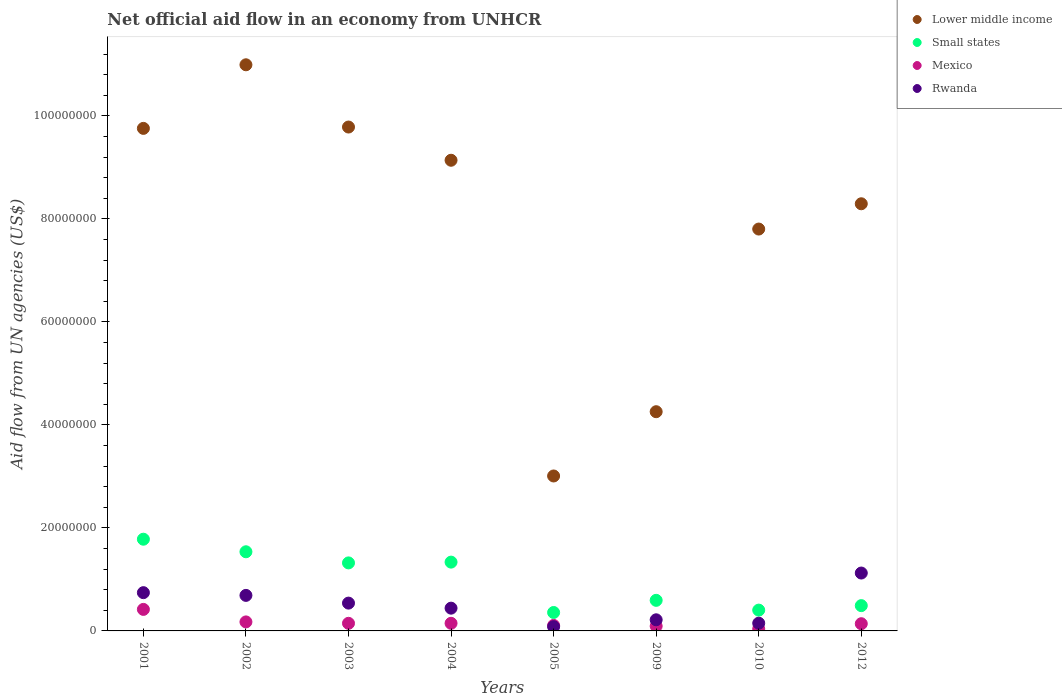How many different coloured dotlines are there?
Offer a terse response. 4. What is the net official aid flow in Rwanda in 2009?
Give a very brief answer. 2.16e+06. Across all years, what is the maximum net official aid flow in Lower middle income?
Provide a short and direct response. 1.10e+08. Across all years, what is the minimum net official aid flow in Small states?
Give a very brief answer. 3.58e+06. In which year was the net official aid flow in Rwanda maximum?
Keep it short and to the point. 2012. What is the total net official aid flow in Small states in the graph?
Your answer should be compact. 7.82e+07. What is the difference between the net official aid flow in Rwanda in 2002 and the net official aid flow in Mexico in 2009?
Keep it short and to the point. 5.97e+06. What is the average net official aid flow in Lower middle income per year?
Offer a terse response. 7.88e+07. In the year 2010, what is the difference between the net official aid flow in Small states and net official aid flow in Lower middle income?
Your answer should be compact. -7.40e+07. In how many years, is the net official aid flow in Rwanda greater than 88000000 US$?
Ensure brevity in your answer.  0. What is the ratio of the net official aid flow in Lower middle income in 2001 to that in 2003?
Keep it short and to the point. 1. What is the difference between the highest and the second highest net official aid flow in Rwanda?
Make the answer very short. 3.81e+06. What is the difference between the highest and the lowest net official aid flow in Small states?
Offer a very short reply. 1.42e+07. In how many years, is the net official aid flow in Lower middle income greater than the average net official aid flow in Lower middle income taken over all years?
Keep it short and to the point. 5. Is the sum of the net official aid flow in Lower middle income in 2005 and 2009 greater than the maximum net official aid flow in Mexico across all years?
Offer a very short reply. Yes. Is it the case that in every year, the sum of the net official aid flow in Lower middle income and net official aid flow in Rwanda  is greater than the sum of net official aid flow in Small states and net official aid flow in Mexico?
Provide a short and direct response. No. How many dotlines are there?
Your response must be concise. 4. What is the title of the graph?
Your answer should be very brief. Net official aid flow in an economy from UNHCR. What is the label or title of the Y-axis?
Provide a succinct answer. Aid flow from UN agencies (US$). What is the Aid flow from UN agencies (US$) in Lower middle income in 2001?
Offer a very short reply. 9.76e+07. What is the Aid flow from UN agencies (US$) of Small states in 2001?
Your response must be concise. 1.78e+07. What is the Aid flow from UN agencies (US$) of Mexico in 2001?
Provide a short and direct response. 4.18e+06. What is the Aid flow from UN agencies (US$) in Rwanda in 2001?
Your answer should be compact. 7.43e+06. What is the Aid flow from UN agencies (US$) of Lower middle income in 2002?
Make the answer very short. 1.10e+08. What is the Aid flow from UN agencies (US$) of Small states in 2002?
Make the answer very short. 1.54e+07. What is the Aid flow from UN agencies (US$) of Mexico in 2002?
Provide a short and direct response. 1.75e+06. What is the Aid flow from UN agencies (US$) of Rwanda in 2002?
Offer a very short reply. 6.90e+06. What is the Aid flow from UN agencies (US$) of Lower middle income in 2003?
Make the answer very short. 9.78e+07. What is the Aid flow from UN agencies (US$) of Small states in 2003?
Make the answer very short. 1.32e+07. What is the Aid flow from UN agencies (US$) of Mexico in 2003?
Offer a terse response. 1.48e+06. What is the Aid flow from UN agencies (US$) of Rwanda in 2003?
Give a very brief answer. 5.40e+06. What is the Aid flow from UN agencies (US$) in Lower middle income in 2004?
Ensure brevity in your answer.  9.14e+07. What is the Aid flow from UN agencies (US$) of Small states in 2004?
Your response must be concise. 1.34e+07. What is the Aid flow from UN agencies (US$) in Mexico in 2004?
Ensure brevity in your answer.  1.48e+06. What is the Aid flow from UN agencies (US$) in Rwanda in 2004?
Offer a terse response. 4.42e+06. What is the Aid flow from UN agencies (US$) of Lower middle income in 2005?
Keep it short and to the point. 3.01e+07. What is the Aid flow from UN agencies (US$) of Small states in 2005?
Ensure brevity in your answer.  3.58e+06. What is the Aid flow from UN agencies (US$) of Mexico in 2005?
Provide a succinct answer. 1.07e+06. What is the Aid flow from UN agencies (US$) in Rwanda in 2005?
Your answer should be very brief. 8.20e+05. What is the Aid flow from UN agencies (US$) of Lower middle income in 2009?
Your answer should be very brief. 4.26e+07. What is the Aid flow from UN agencies (US$) in Small states in 2009?
Offer a very short reply. 5.94e+06. What is the Aid flow from UN agencies (US$) in Mexico in 2009?
Your response must be concise. 9.30e+05. What is the Aid flow from UN agencies (US$) in Rwanda in 2009?
Give a very brief answer. 2.16e+06. What is the Aid flow from UN agencies (US$) in Lower middle income in 2010?
Make the answer very short. 7.80e+07. What is the Aid flow from UN agencies (US$) in Small states in 2010?
Make the answer very short. 4.04e+06. What is the Aid flow from UN agencies (US$) in Rwanda in 2010?
Provide a succinct answer. 1.50e+06. What is the Aid flow from UN agencies (US$) of Lower middle income in 2012?
Provide a short and direct response. 8.30e+07. What is the Aid flow from UN agencies (US$) of Small states in 2012?
Provide a succinct answer. 4.91e+06. What is the Aid flow from UN agencies (US$) of Mexico in 2012?
Provide a succinct answer. 1.40e+06. What is the Aid flow from UN agencies (US$) in Rwanda in 2012?
Your response must be concise. 1.12e+07. Across all years, what is the maximum Aid flow from UN agencies (US$) of Lower middle income?
Your answer should be very brief. 1.10e+08. Across all years, what is the maximum Aid flow from UN agencies (US$) of Small states?
Provide a succinct answer. 1.78e+07. Across all years, what is the maximum Aid flow from UN agencies (US$) in Mexico?
Offer a terse response. 4.18e+06. Across all years, what is the maximum Aid flow from UN agencies (US$) in Rwanda?
Offer a terse response. 1.12e+07. Across all years, what is the minimum Aid flow from UN agencies (US$) of Lower middle income?
Provide a succinct answer. 3.01e+07. Across all years, what is the minimum Aid flow from UN agencies (US$) in Small states?
Your answer should be very brief. 3.58e+06. Across all years, what is the minimum Aid flow from UN agencies (US$) of Mexico?
Keep it short and to the point. 3.90e+05. Across all years, what is the minimum Aid flow from UN agencies (US$) in Rwanda?
Your answer should be very brief. 8.20e+05. What is the total Aid flow from UN agencies (US$) of Lower middle income in the graph?
Your answer should be very brief. 6.30e+08. What is the total Aid flow from UN agencies (US$) in Small states in the graph?
Your answer should be very brief. 7.82e+07. What is the total Aid flow from UN agencies (US$) of Mexico in the graph?
Give a very brief answer. 1.27e+07. What is the total Aid flow from UN agencies (US$) of Rwanda in the graph?
Your answer should be very brief. 3.99e+07. What is the difference between the Aid flow from UN agencies (US$) of Lower middle income in 2001 and that in 2002?
Give a very brief answer. -1.24e+07. What is the difference between the Aid flow from UN agencies (US$) in Small states in 2001 and that in 2002?
Offer a very short reply. 2.44e+06. What is the difference between the Aid flow from UN agencies (US$) in Mexico in 2001 and that in 2002?
Offer a terse response. 2.43e+06. What is the difference between the Aid flow from UN agencies (US$) in Rwanda in 2001 and that in 2002?
Provide a short and direct response. 5.30e+05. What is the difference between the Aid flow from UN agencies (US$) of Lower middle income in 2001 and that in 2003?
Make the answer very short. -2.60e+05. What is the difference between the Aid flow from UN agencies (US$) of Small states in 2001 and that in 2003?
Provide a short and direct response. 4.60e+06. What is the difference between the Aid flow from UN agencies (US$) in Mexico in 2001 and that in 2003?
Offer a very short reply. 2.70e+06. What is the difference between the Aid flow from UN agencies (US$) in Rwanda in 2001 and that in 2003?
Make the answer very short. 2.03e+06. What is the difference between the Aid flow from UN agencies (US$) in Lower middle income in 2001 and that in 2004?
Ensure brevity in your answer.  6.19e+06. What is the difference between the Aid flow from UN agencies (US$) of Small states in 2001 and that in 2004?
Your response must be concise. 4.45e+06. What is the difference between the Aid flow from UN agencies (US$) in Mexico in 2001 and that in 2004?
Give a very brief answer. 2.70e+06. What is the difference between the Aid flow from UN agencies (US$) of Rwanda in 2001 and that in 2004?
Provide a short and direct response. 3.01e+06. What is the difference between the Aid flow from UN agencies (US$) in Lower middle income in 2001 and that in 2005?
Make the answer very short. 6.75e+07. What is the difference between the Aid flow from UN agencies (US$) in Small states in 2001 and that in 2005?
Your answer should be compact. 1.42e+07. What is the difference between the Aid flow from UN agencies (US$) of Mexico in 2001 and that in 2005?
Ensure brevity in your answer.  3.11e+06. What is the difference between the Aid flow from UN agencies (US$) of Rwanda in 2001 and that in 2005?
Offer a very short reply. 6.61e+06. What is the difference between the Aid flow from UN agencies (US$) in Lower middle income in 2001 and that in 2009?
Offer a terse response. 5.50e+07. What is the difference between the Aid flow from UN agencies (US$) in Small states in 2001 and that in 2009?
Offer a very short reply. 1.19e+07. What is the difference between the Aid flow from UN agencies (US$) of Mexico in 2001 and that in 2009?
Your response must be concise. 3.25e+06. What is the difference between the Aid flow from UN agencies (US$) in Rwanda in 2001 and that in 2009?
Make the answer very short. 5.27e+06. What is the difference between the Aid flow from UN agencies (US$) of Lower middle income in 2001 and that in 2010?
Give a very brief answer. 1.96e+07. What is the difference between the Aid flow from UN agencies (US$) in Small states in 2001 and that in 2010?
Your answer should be very brief. 1.38e+07. What is the difference between the Aid flow from UN agencies (US$) in Mexico in 2001 and that in 2010?
Your answer should be very brief. 3.79e+06. What is the difference between the Aid flow from UN agencies (US$) in Rwanda in 2001 and that in 2010?
Your answer should be very brief. 5.93e+06. What is the difference between the Aid flow from UN agencies (US$) in Lower middle income in 2001 and that in 2012?
Provide a succinct answer. 1.46e+07. What is the difference between the Aid flow from UN agencies (US$) in Small states in 2001 and that in 2012?
Your response must be concise. 1.29e+07. What is the difference between the Aid flow from UN agencies (US$) of Mexico in 2001 and that in 2012?
Keep it short and to the point. 2.78e+06. What is the difference between the Aid flow from UN agencies (US$) of Rwanda in 2001 and that in 2012?
Keep it short and to the point. -3.81e+06. What is the difference between the Aid flow from UN agencies (US$) in Lower middle income in 2002 and that in 2003?
Offer a terse response. 1.21e+07. What is the difference between the Aid flow from UN agencies (US$) of Small states in 2002 and that in 2003?
Give a very brief answer. 2.16e+06. What is the difference between the Aid flow from UN agencies (US$) in Mexico in 2002 and that in 2003?
Give a very brief answer. 2.70e+05. What is the difference between the Aid flow from UN agencies (US$) in Rwanda in 2002 and that in 2003?
Offer a terse response. 1.50e+06. What is the difference between the Aid flow from UN agencies (US$) in Lower middle income in 2002 and that in 2004?
Keep it short and to the point. 1.85e+07. What is the difference between the Aid flow from UN agencies (US$) in Small states in 2002 and that in 2004?
Your answer should be very brief. 2.01e+06. What is the difference between the Aid flow from UN agencies (US$) of Rwanda in 2002 and that in 2004?
Offer a terse response. 2.48e+06. What is the difference between the Aid flow from UN agencies (US$) in Lower middle income in 2002 and that in 2005?
Ensure brevity in your answer.  7.98e+07. What is the difference between the Aid flow from UN agencies (US$) of Small states in 2002 and that in 2005?
Your response must be concise. 1.18e+07. What is the difference between the Aid flow from UN agencies (US$) in Mexico in 2002 and that in 2005?
Provide a succinct answer. 6.80e+05. What is the difference between the Aid flow from UN agencies (US$) of Rwanda in 2002 and that in 2005?
Provide a succinct answer. 6.08e+06. What is the difference between the Aid flow from UN agencies (US$) of Lower middle income in 2002 and that in 2009?
Offer a very short reply. 6.74e+07. What is the difference between the Aid flow from UN agencies (US$) of Small states in 2002 and that in 2009?
Your answer should be very brief. 9.43e+06. What is the difference between the Aid flow from UN agencies (US$) in Mexico in 2002 and that in 2009?
Offer a very short reply. 8.20e+05. What is the difference between the Aid flow from UN agencies (US$) in Rwanda in 2002 and that in 2009?
Keep it short and to the point. 4.74e+06. What is the difference between the Aid flow from UN agencies (US$) in Lower middle income in 2002 and that in 2010?
Give a very brief answer. 3.19e+07. What is the difference between the Aid flow from UN agencies (US$) of Small states in 2002 and that in 2010?
Give a very brief answer. 1.13e+07. What is the difference between the Aid flow from UN agencies (US$) in Mexico in 2002 and that in 2010?
Provide a short and direct response. 1.36e+06. What is the difference between the Aid flow from UN agencies (US$) of Rwanda in 2002 and that in 2010?
Offer a terse response. 5.40e+06. What is the difference between the Aid flow from UN agencies (US$) of Lower middle income in 2002 and that in 2012?
Make the answer very short. 2.70e+07. What is the difference between the Aid flow from UN agencies (US$) in Small states in 2002 and that in 2012?
Make the answer very short. 1.05e+07. What is the difference between the Aid flow from UN agencies (US$) of Mexico in 2002 and that in 2012?
Your answer should be compact. 3.50e+05. What is the difference between the Aid flow from UN agencies (US$) in Rwanda in 2002 and that in 2012?
Your response must be concise. -4.34e+06. What is the difference between the Aid flow from UN agencies (US$) in Lower middle income in 2003 and that in 2004?
Provide a short and direct response. 6.45e+06. What is the difference between the Aid flow from UN agencies (US$) in Small states in 2003 and that in 2004?
Offer a very short reply. -1.50e+05. What is the difference between the Aid flow from UN agencies (US$) in Rwanda in 2003 and that in 2004?
Keep it short and to the point. 9.80e+05. What is the difference between the Aid flow from UN agencies (US$) in Lower middle income in 2003 and that in 2005?
Provide a short and direct response. 6.78e+07. What is the difference between the Aid flow from UN agencies (US$) of Small states in 2003 and that in 2005?
Keep it short and to the point. 9.63e+06. What is the difference between the Aid flow from UN agencies (US$) of Mexico in 2003 and that in 2005?
Provide a short and direct response. 4.10e+05. What is the difference between the Aid flow from UN agencies (US$) of Rwanda in 2003 and that in 2005?
Your answer should be compact. 4.58e+06. What is the difference between the Aid flow from UN agencies (US$) in Lower middle income in 2003 and that in 2009?
Provide a short and direct response. 5.53e+07. What is the difference between the Aid flow from UN agencies (US$) in Small states in 2003 and that in 2009?
Provide a succinct answer. 7.27e+06. What is the difference between the Aid flow from UN agencies (US$) in Rwanda in 2003 and that in 2009?
Make the answer very short. 3.24e+06. What is the difference between the Aid flow from UN agencies (US$) in Lower middle income in 2003 and that in 2010?
Ensure brevity in your answer.  1.98e+07. What is the difference between the Aid flow from UN agencies (US$) of Small states in 2003 and that in 2010?
Provide a short and direct response. 9.17e+06. What is the difference between the Aid flow from UN agencies (US$) of Mexico in 2003 and that in 2010?
Provide a short and direct response. 1.09e+06. What is the difference between the Aid flow from UN agencies (US$) of Rwanda in 2003 and that in 2010?
Your answer should be compact. 3.90e+06. What is the difference between the Aid flow from UN agencies (US$) of Lower middle income in 2003 and that in 2012?
Provide a succinct answer. 1.49e+07. What is the difference between the Aid flow from UN agencies (US$) of Small states in 2003 and that in 2012?
Offer a very short reply. 8.30e+06. What is the difference between the Aid flow from UN agencies (US$) in Rwanda in 2003 and that in 2012?
Make the answer very short. -5.84e+06. What is the difference between the Aid flow from UN agencies (US$) in Lower middle income in 2004 and that in 2005?
Provide a short and direct response. 6.13e+07. What is the difference between the Aid flow from UN agencies (US$) of Small states in 2004 and that in 2005?
Your answer should be compact. 9.78e+06. What is the difference between the Aid flow from UN agencies (US$) in Mexico in 2004 and that in 2005?
Provide a short and direct response. 4.10e+05. What is the difference between the Aid flow from UN agencies (US$) of Rwanda in 2004 and that in 2005?
Give a very brief answer. 3.60e+06. What is the difference between the Aid flow from UN agencies (US$) of Lower middle income in 2004 and that in 2009?
Keep it short and to the point. 4.88e+07. What is the difference between the Aid flow from UN agencies (US$) of Small states in 2004 and that in 2009?
Make the answer very short. 7.42e+06. What is the difference between the Aid flow from UN agencies (US$) of Mexico in 2004 and that in 2009?
Your response must be concise. 5.50e+05. What is the difference between the Aid flow from UN agencies (US$) in Rwanda in 2004 and that in 2009?
Provide a short and direct response. 2.26e+06. What is the difference between the Aid flow from UN agencies (US$) of Lower middle income in 2004 and that in 2010?
Make the answer very short. 1.34e+07. What is the difference between the Aid flow from UN agencies (US$) of Small states in 2004 and that in 2010?
Ensure brevity in your answer.  9.32e+06. What is the difference between the Aid flow from UN agencies (US$) in Mexico in 2004 and that in 2010?
Offer a terse response. 1.09e+06. What is the difference between the Aid flow from UN agencies (US$) of Rwanda in 2004 and that in 2010?
Offer a terse response. 2.92e+06. What is the difference between the Aid flow from UN agencies (US$) in Lower middle income in 2004 and that in 2012?
Ensure brevity in your answer.  8.45e+06. What is the difference between the Aid flow from UN agencies (US$) in Small states in 2004 and that in 2012?
Ensure brevity in your answer.  8.45e+06. What is the difference between the Aid flow from UN agencies (US$) of Rwanda in 2004 and that in 2012?
Provide a succinct answer. -6.82e+06. What is the difference between the Aid flow from UN agencies (US$) in Lower middle income in 2005 and that in 2009?
Keep it short and to the point. -1.25e+07. What is the difference between the Aid flow from UN agencies (US$) in Small states in 2005 and that in 2009?
Provide a short and direct response. -2.36e+06. What is the difference between the Aid flow from UN agencies (US$) in Rwanda in 2005 and that in 2009?
Offer a terse response. -1.34e+06. What is the difference between the Aid flow from UN agencies (US$) in Lower middle income in 2005 and that in 2010?
Offer a terse response. -4.80e+07. What is the difference between the Aid flow from UN agencies (US$) of Small states in 2005 and that in 2010?
Provide a short and direct response. -4.60e+05. What is the difference between the Aid flow from UN agencies (US$) of Mexico in 2005 and that in 2010?
Your answer should be compact. 6.80e+05. What is the difference between the Aid flow from UN agencies (US$) in Rwanda in 2005 and that in 2010?
Offer a very short reply. -6.80e+05. What is the difference between the Aid flow from UN agencies (US$) in Lower middle income in 2005 and that in 2012?
Give a very brief answer. -5.29e+07. What is the difference between the Aid flow from UN agencies (US$) of Small states in 2005 and that in 2012?
Keep it short and to the point. -1.33e+06. What is the difference between the Aid flow from UN agencies (US$) in Mexico in 2005 and that in 2012?
Make the answer very short. -3.30e+05. What is the difference between the Aid flow from UN agencies (US$) in Rwanda in 2005 and that in 2012?
Ensure brevity in your answer.  -1.04e+07. What is the difference between the Aid flow from UN agencies (US$) of Lower middle income in 2009 and that in 2010?
Provide a short and direct response. -3.55e+07. What is the difference between the Aid flow from UN agencies (US$) of Small states in 2009 and that in 2010?
Ensure brevity in your answer.  1.90e+06. What is the difference between the Aid flow from UN agencies (US$) in Mexico in 2009 and that in 2010?
Keep it short and to the point. 5.40e+05. What is the difference between the Aid flow from UN agencies (US$) of Lower middle income in 2009 and that in 2012?
Provide a short and direct response. -4.04e+07. What is the difference between the Aid flow from UN agencies (US$) in Small states in 2009 and that in 2012?
Offer a very short reply. 1.03e+06. What is the difference between the Aid flow from UN agencies (US$) in Mexico in 2009 and that in 2012?
Your answer should be very brief. -4.70e+05. What is the difference between the Aid flow from UN agencies (US$) in Rwanda in 2009 and that in 2012?
Offer a terse response. -9.08e+06. What is the difference between the Aid flow from UN agencies (US$) in Lower middle income in 2010 and that in 2012?
Offer a terse response. -4.91e+06. What is the difference between the Aid flow from UN agencies (US$) of Small states in 2010 and that in 2012?
Your response must be concise. -8.70e+05. What is the difference between the Aid flow from UN agencies (US$) of Mexico in 2010 and that in 2012?
Provide a succinct answer. -1.01e+06. What is the difference between the Aid flow from UN agencies (US$) in Rwanda in 2010 and that in 2012?
Make the answer very short. -9.74e+06. What is the difference between the Aid flow from UN agencies (US$) of Lower middle income in 2001 and the Aid flow from UN agencies (US$) of Small states in 2002?
Your response must be concise. 8.22e+07. What is the difference between the Aid flow from UN agencies (US$) in Lower middle income in 2001 and the Aid flow from UN agencies (US$) in Mexico in 2002?
Provide a succinct answer. 9.58e+07. What is the difference between the Aid flow from UN agencies (US$) in Lower middle income in 2001 and the Aid flow from UN agencies (US$) in Rwanda in 2002?
Make the answer very short. 9.07e+07. What is the difference between the Aid flow from UN agencies (US$) in Small states in 2001 and the Aid flow from UN agencies (US$) in Mexico in 2002?
Your answer should be compact. 1.61e+07. What is the difference between the Aid flow from UN agencies (US$) of Small states in 2001 and the Aid flow from UN agencies (US$) of Rwanda in 2002?
Ensure brevity in your answer.  1.09e+07. What is the difference between the Aid flow from UN agencies (US$) of Mexico in 2001 and the Aid flow from UN agencies (US$) of Rwanda in 2002?
Your answer should be compact. -2.72e+06. What is the difference between the Aid flow from UN agencies (US$) of Lower middle income in 2001 and the Aid flow from UN agencies (US$) of Small states in 2003?
Your answer should be very brief. 8.44e+07. What is the difference between the Aid flow from UN agencies (US$) of Lower middle income in 2001 and the Aid flow from UN agencies (US$) of Mexico in 2003?
Offer a very short reply. 9.61e+07. What is the difference between the Aid flow from UN agencies (US$) in Lower middle income in 2001 and the Aid flow from UN agencies (US$) in Rwanda in 2003?
Offer a terse response. 9.22e+07. What is the difference between the Aid flow from UN agencies (US$) of Small states in 2001 and the Aid flow from UN agencies (US$) of Mexico in 2003?
Ensure brevity in your answer.  1.63e+07. What is the difference between the Aid flow from UN agencies (US$) in Small states in 2001 and the Aid flow from UN agencies (US$) in Rwanda in 2003?
Your answer should be very brief. 1.24e+07. What is the difference between the Aid flow from UN agencies (US$) of Mexico in 2001 and the Aid flow from UN agencies (US$) of Rwanda in 2003?
Provide a short and direct response. -1.22e+06. What is the difference between the Aid flow from UN agencies (US$) of Lower middle income in 2001 and the Aid flow from UN agencies (US$) of Small states in 2004?
Make the answer very short. 8.42e+07. What is the difference between the Aid flow from UN agencies (US$) in Lower middle income in 2001 and the Aid flow from UN agencies (US$) in Mexico in 2004?
Make the answer very short. 9.61e+07. What is the difference between the Aid flow from UN agencies (US$) in Lower middle income in 2001 and the Aid flow from UN agencies (US$) in Rwanda in 2004?
Keep it short and to the point. 9.32e+07. What is the difference between the Aid flow from UN agencies (US$) of Small states in 2001 and the Aid flow from UN agencies (US$) of Mexico in 2004?
Your answer should be compact. 1.63e+07. What is the difference between the Aid flow from UN agencies (US$) of Small states in 2001 and the Aid flow from UN agencies (US$) of Rwanda in 2004?
Provide a succinct answer. 1.34e+07. What is the difference between the Aid flow from UN agencies (US$) of Mexico in 2001 and the Aid flow from UN agencies (US$) of Rwanda in 2004?
Provide a succinct answer. -2.40e+05. What is the difference between the Aid flow from UN agencies (US$) in Lower middle income in 2001 and the Aid flow from UN agencies (US$) in Small states in 2005?
Give a very brief answer. 9.40e+07. What is the difference between the Aid flow from UN agencies (US$) of Lower middle income in 2001 and the Aid flow from UN agencies (US$) of Mexico in 2005?
Your answer should be very brief. 9.65e+07. What is the difference between the Aid flow from UN agencies (US$) in Lower middle income in 2001 and the Aid flow from UN agencies (US$) in Rwanda in 2005?
Your response must be concise. 9.68e+07. What is the difference between the Aid flow from UN agencies (US$) of Small states in 2001 and the Aid flow from UN agencies (US$) of Mexico in 2005?
Your answer should be very brief. 1.67e+07. What is the difference between the Aid flow from UN agencies (US$) in Small states in 2001 and the Aid flow from UN agencies (US$) in Rwanda in 2005?
Give a very brief answer. 1.70e+07. What is the difference between the Aid flow from UN agencies (US$) of Mexico in 2001 and the Aid flow from UN agencies (US$) of Rwanda in 2005?
Keep it short and to the point. 3.36e+06. What is the difference between the Aid flow from UN agencies (US$) of Lower middle income in 2001 and the Aid flow from UN agencies (US$) of Small states in 2009?
Offer a terse response. 9.16e+07. What is the difference between the Aid flow from UN agencies (US$) of Lower middle income in 2001 and the Aid flow from UN agencies (US$) of Mexico in 2009?
Offer a very short reply. 9.67e+07. What is the difference between the Aid flow from UN agencies (US$) of Lower middle income in 2001 and the Aid flow from UN agencies (US$) of Rwanda in 2009?
Offer a very short reply. 9.54e+07. What is the difference between the Aid flow from UN agencies (US$) of Small states in 2001 and the Aid flow from UN agencies (US$) of Mexico in 2009?
Provide a short and direct response. 1.69e+07. What is the difference between the Aid flow from UN agencies (US$) in Small states in 2001 and the Aid flow from UN agencies (US$) in Rwanda in 2009?
Keep it short and to the point. 1.56e+07. What is the difference between the Aid flow from UN agencies (US$) in Mexico in 2001 and the Aid flow from UN agencies (US$) in Rwanda in 2009?
Your answer should be compact. 2.02e+06. What is the difference between the Aid flow from UN agencies (US$) in Lower middle income in 2001 and the Aid flow from UN agencies (US$) in Small states in 2010?
Offer a very short reply. 9.36e+07. What is the difference between the Aid flow from UN agencies (US$) of Lower middle income in 2001 and the Aid flow from UN agencies (US$) of Mexico in 2010?
Give a very brief answer. 9.72e+07. What is the difference between the Aid flow from UN agencies (US$) in Lower middle income in 2001 and the Aid flow from UN agencies (US$) in Rwanda in 2010?
Give a very brief answer. 9.61e+07. What is the difference between the Aid flow from UN agencies (US$) in Small states in 2001 and the Aid flow from UN agencies (US$) in Mexico in 2010?
Your answer should be very brief. 1.74e+07. What is the difference between the Aid flow from UN agencies (US$) in Small states in 2001 and the Aid flow from UN agencies (US$) in Rwanda in 2010?
Ensure brevity in your answer.  1.63e+07. What is the difference between the Aid flow from UN agencies (US$) in Mexico in 2001 and the Aid flow from UN agencies (US$) in Rwanda in 2010?
Keep it short and to the point. 2.68e+06. What is the difference between the Aid flow from UN agencies (US$) of Lower middle income in 2001 and the Aid flow from UN agencies (US$) of Small states in 2012?
Offer a terse response. 9.27e+07. What is the difference between the Aid flow from UN agencies (US$) of Lower middle income in 2001 and the Aid flow from UN agencies (US$) of Mexico in 2012?
Your answer should be very brief. 9.62e+07. What is the difference between the Aid flow from UN agencies (US$) in Lower middle income in 2001 and the Aid flow from UN agencies (US$) in Rwanda in 2012?
Make the answer very short. 8.64e+07. What is the difference between the Aid flow from UN agencies (US$) in Small states in 2001 and the Aid flow from UN agencies (US$) in Mexico in 2012?
Provide a short and direct response. 1.64e+07. What is the difference between the Aid flow from UN agencies (US$) in Small states in 2001 and the Aid flow from UN agencies (US$) in Rwanda in 2012?
Make the answer very short. 6.57e+06. What is the difference between the Aid flow from UN agencies (US$) of Mexico in 2001 and the Aid flow from UN agencies (US$) of Rwanda in 2012?
Your answer should be compact. -7.06e+06. What is the difference between the Aid flow from UN agencies (US$) in Lower middle income in 2002 and the Aid flow from UN agencies (US$) in Small states in 2003?
Provide a short and direct response. 9.67e+07. What is the difference between the Aid flow from UN agencies (US$) in Lower middle income in 2002 and the Aid flow from UN agencies (US$) in Mexico in 2003?
Keep it short and to the point. 1.08e+08. What is the difference between the Aid flow from UN agencies (US$) of Lower middle income in 2002 and the Aid flow from UN agencies (US$) of Rwanda in 2003?
Your answer should be compact. 1.05e+08. What is the difference between the Aid flow from UN agencies (US$) of Small states in 2002 and the Aid flow from UN agencies (US$) of Mexico in 2003?
Your answer should be compact. 1.39e+07. What is the difference between the Aid flow from UN agencies (US$) in Small states in 2002 and the Aid flow from UN agencies (US$) in Rwanda in 2003?
Offer a terse response. 9.97e+06. What is the difference between the Aid flow from UN agencies (US$) of Mexico in 2002 and the Aid flow from UN agencies (US$) of Rwanda in 2003?
Your answer should be very brief. -3.65e+06. What is the difference between the Aid flow from UN agencies (US$) of Lower middle income in 2002 and the Aid flow from UN agencies (US$) of Small states in 2004?
Offer a terse response. 9.66e+07. What is the difference between the Aid flow from UN agencies (US$) in Lower middle income in 2002 and the Aid flow from UN agencies (US$) in Mexico in 2004?
Your answer should be very brief. 1.08e+08. What is the difference between the Aid flow from UN agencies (US$) of Lower middle income in 2002 and the Aid flow from UN agencies (US$) of Rwanda in 2004?
Ensure brevity in your answer.  1.06e+08. What is the difference between the Aid flow from UN agencies (US$) in Small states in 2002 and the Aid flow from UN agencies (US$) in Mexico in 2004?
Your response must be concise. 1.39e+07. What is the difference between the Aid flow from UN agencies (US$) in Small states in 2002 and the Aid flow from UN agencies (US$) in Rwanda in 2004?
Your response must be concise. 1.10e+07. What is the difference between the Aid flow from UN agencies (US$) in Mexico in 2002 and the Aid flow from UN agencies (US$) in Rwanda in 2004?
Provide a succinct answer. -2.67e+06. What is the difference between the Aid flow from UN agencies (US$) of Lower middle income in 2002 and the Aid flow from UN agencies (US$) of Small states in 2005?
Provide a short and direct response. 1.06e+08. What is the difference between the Aid flow from UN agencies (US$) in Lower middle income in 2002 and the Aid flow from UN agencies (US$) in Mexico in 2005?
Offer a terse response. 1.09e+08. What is the difference between the Aid flow from UN agencies (US$) in Lower middle income in 2002 and the Aid flow from UN agencies (US$) in Rwanda in 2005?
Your answer should be very brief. 1.09e+08. What is the difference between the Aid flow from UN agencies (US$) in Small states in 2002 and the Aid flow from UN agencies (US$) in Mexico in 2005?
Offer a very short reply. 1.43e+07. What is the difference between the Aid flow from UN agencies (US$) in Small states in 2002 and the Aid flow from UN agencies (US$) in Rwanda in 2005?
Your answer should be compact. 1.46e+07. What is the difference between the Aid flow from UN agencies (US$) of Mexico in 2002 and the Aid flow from UN agencies (US$) of Rwanda in 2005?
Your answer should be very brief. 9.30e+05. What is the difference between the Aid flow from UN agencies (US$) in Lower middle income in 2002 and the Aid flow from UN agencies (US$) in Small states in 2009?
Your answer should be compact. 1.04e+08. What is the difference between the Aid flow from UN agencies (US$) in Lower middle income in 2002 and the Aid flow from UN agencies (US$) in Mexico in 2009?
Your answer should be compact. 1.09e+08. What is the difference between the Aid flow from UN agencies (US$) in Lower middle income in 2002 and the Aid flow from UN agencies (US$) in Rwanda in 2009?
Your answer should be very brief. 1.08e+08. What is the difference between the Aid flow from UN agencies (US$) of Small states in 2002 and the Aid flow from UN agencies (US$) of Mexico in 2009?
Ensure brevity in your answer.  1.44e+07. What is the difference between the Aid flow from UN agencies (US$) of Small states in 2002 and the Aid flow from UN agencies (US$) of Rwanda in 2009?
Your answer should be compact. 1.32e+07. What is the difference between the Aid flow from UN agencies (US$) of Mexico in 2002 and the Aid flow from UN agencies (US$) of Rwanda in 2009?
Your answer should be compact. -4.10e+05. What is the difference between the Aid flow from UN agencies (US$) in Lower middle income in 2002 and the Aid flow from UN agencies (US$) in Small states in 2010?
Give a very brief answer. 1.06e+08. What is the difference between the Aid flow from UN agencies (US$) in Lower middle income in 2002 and the Aid flow from UN agencies (US$) in Mexico in 2010?
Give a very brief answer. 1.10e+08. What is the difference between the Aid flow from UN agencies (US$) of Lower middle income in 2002 and the Aid flow from UN agencies (US$) of Rwanda in 2010?
Provide a short and direct response. 1.08e+08. What is the difference between the Aid flow from UN agencies (US$) in Small states in 2002 and the Aid flow from UN agencies (US$) in Mexico in 2010?
Make the answer very short. 1.50e+07. What is the difference between the Aid flow from UN agencies (US$) in Small states in 2002 and the Aid flow from UN agencies (US$) in Rwanda in 2010?
Offer a very short reply. 1.39e+07. What is the difference between the Aid flow from UN agencies (US$) in Lower middle income in 2002 and the Aid flow from UN agencies (US$) in Small states in 2012?
Give a very brief answer. 1.05e+08. What is the difference between the Aid flow from UN agencies (US$) of Lower middle income in 2002 and the Aid flow from UN agencies (US$) of Mexico in 2012?
Your response must be concise. 1.09e+08. What is the difference between the Aid flow from UN agencies (US$) in Lower middle income in 2002 and the Aid flow from UN agencies (US$) in Rwanda in 2012?
Provide a short and direct response. 9.87e+07. What is the difference between the Aid flow from UN agencies (US$) of Small states in 2002 and the Aid flow from UN agencies (US$) of Mexico in 2012?
Keep it short and to the point. 1.40e+07. What is the difference between the Aid flow from UN agencies (US$) of Small states in 2002 and the Aid flow from UN agencies (US$) of Rwanda in 2012?
Provide a short and direct response. 4.13e+06. What is the difference between the Aid flow from UN agencies (US$) of Mexico in 2002 and the Aid flow from UN agencies (US$) of Rwanda in 2012?
Your answer should be very brief. -9.49e+06. What is the difference between the Aid flow from UN agencies (US$) in Lower middle income in 2003 and the Aid flow from UN agencies (US$) in Small states in 2004?
Make the answer very short. 8.45e+07. What is the difference between the Aid flow from UN agencies (US$) in Lower middle income in 2003 and the Aid flow from UN agencies (US$) in Mexico in 2004?
Your response must be concise. 9.64e+07. What is the difference between the Aid flow from UN agencies (US$) of Lower middle income in 2003 and the Aid flow from UN agencies (US$) of Rwanda in 2004?
Provide a succinct answer. 9.34e+07. What is the difference between the Aid flow from UN agencies (US$) in Small states in 2003 and the Aid flow from UN agencies (US$) in Mexico in 2004?
Offer a terse response. 1.17e+07. What is the difference between the Aid flow from UN agencies (US$) in Small states in 2003 and the Aid flow from UN agencies (US$) in Rwanda in 2004?
Ensure brevity in your answer.  8.79e+06. What is the difference between the Aid flow from UN agencies (US$) of Mexico in 2003 and the Aid flow from UN agencies (US$) of Rwanda in 2004?
Keep it short and to the point. -2.94e+06. What is the difference between the Aid flow from UN agencies (US$) in Lower middle income in 2003 and the Aid flow from UN agencies (US$) in Small states in 2005?
Ensure brevity in your answer.  9.43e+07. What is the difference between the Aid flow from UN agencies (US$) in Lower middle income in 2003 and the Aid flow from UN agencies (US$) in Mexico in 2005?
Provide a succinct answer. 9.68e+07. What is the difference between the Aid flow from UN agencies (US$) of Lower middle income in 2003 and the Aid flow from UN agencies (US$) of Rwanda in 2005?
Keep it short and to the point. 9.70e+07. What is the difference between the Aid flow from UN agencies (US$) of Small states in 2003 and the Aid flow from UN agencies (US$) of Mexico in 2005?
Offer a very short reply. 1.21e+07. What is the difference between the Aid flow from UN agencies (US$) in Small states in 2003 and the Aid flow from UN agencies (US$) in Rwanda in 2005?
Offer a terse response. 1.24e+07. What is the difference between the Aid flow from UN agencies (US$) in Mexico in 2003 and the Aid flow from UN agencies (US$) in Rwanda in 2005?
Make the answer very short. 6.60e+05. What is the difference between the Aid flow from UN agencies (US$) in Lower middle income in 2003 and the Aid flow from UN agencies (US$) in Small states in 2009?
Offer a very short reply. 9.19e+07. What is the difference between the Aid flow from UN agencies (US$) in Lower middle income in 2003 and the Aid flow from UN agencies (US$) in Mexico in 2009?
Provide a short and direct response. 9.69e+07. What is the difference between the Aid flow from UN agencies (US$) of Lower middle income in 2003 and the Aid flow from UN agencies (US$) of Rwanda in 2009?
Your answer should be compact. 9.57e+07. What is the difference between the Aid flow from UN agencies (US$) of Small states in 2003 and the Aid flow from UN agencies (US$) of Mexico in 2009?
Your answer should be very brief. 1.23e+07. What is the difference between the Aid flow from UN agencies (US$) of Small states in 2003 and the Aid flow from UN agencies (US$) of Rwanda in 2009?
Offer a terse response. 1.10e+07. What is the difference between the Aid flow from UN agencies (US$) in Mexico in 2003 and the Aid flow from UN agencies (US$) in Rwanda in 2009?
Provide a succinct answer. -6.80e+05. What is the difference between the Aid flow from UN agencies (US$) in Lower middle income in 2003 and the Aid flow from UN agencies (US$) in Small states in 2010?
Your answer should be very brief. 9.38e+07. What is the difference between the Aid flow from UN agencies (US$) of Lower middle income in 2003 and the Aid flow from UN agencies (US$) of Mexico in 2010?
Provide a short and direct response. 9.75e+07. What is the difference between the Aid flow from UN agencies (US$) of Lower middle income in 2003 and the Aid flow from UN agencies (US$) of Rwanda in 2010?
Ensure brevity in your answer.  9.64e+07. What is the difference between the Aid flow from UN agencies (US$) of Small states in 2003 and the Aid flow from UN agencies (US$) of Mexico in 2010?
Make the answer very short. 1.28e+07. What is the difference between the Aid flow from UN agencies (US$) in Small states in 2003 and the Aid flow from UN agencies (US$) in Rwanda in 2010?
Your response must be concise. 1.17e+07. What is the difference between the Aid flow from UN agencies (US$) in Mexico in 2003 and the Aid flow from UN agencies (US$) in Rwanda in 2010?
Offer a very short reply. -2.00e+04. What is the difference between the Aid flow from UN agencies (US$) in Lower middle income in 2003 and the Aid flow from UN agencies (US$) in Small states in 2012?
Provide a succinct answer. 9.29e+07. What is the difference between the Aid flow from UN agencies (US$) of Lower middle income in 2003 and the Aid flow from UN agencies (US$) of Mexico in 2012?
Your answer should be compact. 9.64e+07. What is the difference between the Aid flow from UN agencies (US$) in Lower middle income in 2003 and the Aid flow from UN agencies (US$) in Rwanda in 2012?
Your response must be concise. 8.66e+07. What is the difference between the Aid flow from UN agencies (US$) in Small states in 2003 and the Aid flow from UN agencies (US$) in Mexico in 2012?
Your answer should be very brief. 1.18e+07. What is the difference between the Aid flow from UN agencies (US$) in Small states in 2003 and the Aid flow from UN agencies (US$) in Rwanda in 2012?
Your answer should be compact. 1.97e+06. What is the difference between the Aid flow from UN agencies (US$) of Mexico in 2003 and the Aid flow from UN agencies (US$) of Rwanda in 2012?
Provide a short and direct response. -9.76e+06. What is the difference between the Aid flow from UN agencies (US$) in Lower middle income in 2004 and the Aid flow from UN agencies (US$) in Small states in 2005?
Your response must be concise. 8.78e+07. What is the difference between the Aid flow from UN agencies (US$) in Lower middle income in 2004 and the Aid flow from UN agencies (US$) in Mexico in 2005?
Your answer should be compact. 9.03e+07. What is the difference between the Aid flow from UN agencies (US$) in Lower middle income in 2004 and the Aid flow from UN agencies (US$) in Rwanda in 2005?
Your answer should be very brief. 9.06e+07. What is the difference between the Aid flow from UN agencies (US$) of Small states in 2004 and the Aid flow from UN agencies (US$) of Mexico in 2005?
Offer a very short reply. 1.23e+07. What is the difference between the Aid flow from UN agencies (US$) in Small states in 2004 and the Aid flow from UN agencies (US$) in Rwanda in 2005?
Ensure brevity in your answer.  1.25e+07. What is the difference between the Aid flow from UN agencies (US$) in Mexico in 2004 and the Aid flow from UN agencies (US$) in Rwanda in 2005?
Offer a very short reply. 6.60e+05. What is the difference between the Aid flow from UN agencies (US$) in Lower middle income in 2004 and the Aid flow from UN agencies (US$) in Small states in 2009?
Keep it short and to the point. 8.55e+07. What is the difference between the Aid flow from UN agencies (US$) in Lower middle income in 2004 and the Aid flow from UN agencies (US$) in Mexico in 2009?
Your response must be concise. 9.05e+07. What is the difference between the Aid flow from UN agencies (US$) of Lower middle income in 2004 and the Aid flow from UN agencies (US$) of Rwanda in 2009?
Ensure brevity in your answer.  8.92e+07. What is the difference between the Aid flow from UN agencies (US$) of Small states in 2004 and the Aid flow from UN agencies (US$) of Mexico in 2009?
Provide a short and direct response. 1.24e+07. What is the difference between the Aid flow from UN agencies (US$) of Small states in 2004 and the Aid flow from UN agencies (US$) of Rwanda in 2009?
Make the answer very short. 1.12e+07. What is the difference between the Aid flow from UN agencies (US$) of Mexico in 2004 and the Aid flow from UN agencies (US$) of Rwanda in 2009?
Give a very brief answer. -6.80e+05. What is the difference between the Aid flow from UN agencies (US$) in Lower middle income in 2004 and the Aid flow from UN agencies (US$) in Small states in 2010?
Your answer should be very brief. 8.74e+07. What is the difference between the Aid flow from UN agencies (US$) of Lower middle income in 2004 and the Aid flow from UN agencies (US$) of Mexico in 2010?
Offer a very short reply. 9.10e+07. What is the difference between the Aid flow from UN agencies (US$) of Lower middle income in 2004 and the Aid flow from UN agencies (US$) of Rwanda in 2010?
Offer a terse response. 8.99e+07. What is the difference between the Aid flow from UN agencies (US$) of Small states in 2004 and the Aid flow from UN agencies (US$) of Mexico in 2010?
Your response must be concise. 1.30e+07. What is the difference between the Aid flow from UN agencies (US$) of Small states in 2004 and the Aid flow from UN agencies (US$) of Rwanda in 2010?
Offer a very short reply. 1.19e+07. What is the difference between the Aid flow from UN agencies (US$) of Lower middle income in 2004 and the Aid flow from UN agencies (US$) of Small states in 2012?
Offer a terse response. 8.65e+07. What is the difference between the Aid flow from UN agencies (US$) in Lower middle income in 2004 and the Aid flow from UN agencies (US$) in Mexico in 2012?
Your answer should be very brief. 9.00e+07. What is the difference between the Aid flow from UN agencies (US$) in Lower middle income in 2004 and the Aid flow from UN agencies (US$) in Rwanda in 2012?
Provide a succinct answer. 8.02e+07. What is the difference between the Aid flow from UN agencies (US$) in Small states in 2004 and the Aid flow from UN agencies (US$) in Mexico in 2012?
Your answer should be very brief. 1.20e+07. What is the difference between the Aid flow from UN agencies (US$) in Small states in 2004 and the Aid flow from UN agencies (US$) in Rwanda in 2012?
Make the answer very short. 2.12e+06. What is the difference between the Aid flow from UN agencies (US$) in Mexico in 2004 and the Aid flow from UN agencies (US$) in Rwanda in 2012?
Ensure brevity in your answer.  -9.76e+06. What is the difference between the Aid flow from UN agencies (US$) of Lower middle income in 2005 and the Aid flow from UN agencies (US$) of Small states in 2009?
Your answer should be compact. 2.42e+07. What is the difference between the Aid flow from UN agencies (US$) of Lower middle income in 2005 and the Aid flow from UN agencies (US$) of Mexico in 2009?
Your answer should be very brief. 2.92e+07. What is the difference between the Aid flow from UN agencies (US$) in Lower middle income in 2005 and the Aid flow from UN agencies (US$) in Rwanda in 2009?
Provide a short and direct response. 2.79e+07. What is the difference between the Aid flow from UN agencies (US$) of Small states in 2005 and the Aid flow from UN agencies (US$) of Mexico in 2009?
Provide a short and direct response. 2.65e+06. What is the difference between the Aid flow from UN agencies (US$) in Small states in 2005 and the Aid flow from UN agencies (US$) in Rwanda in 2009?
Your answer should be compact. 1.42e+06. What is the difference between the Aid flow from UN agencies (US$) in Mexico in 2005 and the Aid flow from UN agencies (US$) in Rwanda in 2009?
Your response must be concise. -1.09e+06. What is the difference between the Aid flow from UN agencies (US$) of Lower middle income in 2005 and the Aid flow from UN agencies (US$) of Small states in 2010?
Make the answer very short. 2.60e+07. What is the difference between the Aid flow from UN agencies (US$) in Lower middle income in 2005 and the Aid flow from UN agencies (US$) in Mexico in 2010?
Offer a very short reply. 2.97e+07. What is the difference between the Aid flow from UN agencies (US$) in Lower middle income in 2005 and the Aid flow from UN agencies (US$) in Rwanda in 2010?
Your answer should be compact. 2.86e+07. What is the difference between the Aid flow from UN agencies (US$) of Small states in 2005 and the Aid flow from UN agencies (US$) of Mexico in 2010?
Provide a short and direct response. 3.19e+06. What is the difference between the Aid flow from UN agencies (US$) in Small states in 2005 and the Aid flow from UN agencies (US$) in Rwanda in 2010?
Keep it short and to the point. 2.08e+06. What is the difference between the Aid flow from UN agencies (US$) in Mexico in 2005 and the Aid flow from UN agencies (US$) in Rwanda in 2010?
Make the answer very short. -4.30e+05. What is the difference between the Aid flow from UN agencies (US$) of Lower middle income in 2005 and the Aid flow from UN agencies (US$) of Small states in 2012?
Your response must be concise. 2.52e+07. What is the difference between the Aid flow from UN agencies (US$) of Lower middle income in 2005 and the Aid flow from UN agencies (US$) of Mexico in 2012?
Offer a terse response. 2.87e+07. What is the difference between the Aid flow from UN agencies (US$) in Lower middle income in 2005 and the Aid flow from UN agencies (US$) in Rwanda in 2012?
Offer a terse response. 1.88e+07. What is the difference between the Aid flow from UN agencies (US$) in Small states in 2005 and the Aid flow from UN agencies (US$) in Mexico in 2012?
Ensure brevity in your answer.  2.18e+06. What is the difference between the Aid flow from UN agencies (US$) in Small states in 2005 and the Aid flow from UN agencies (US$) in Rwanda in 2012?
Make the answer very short. -7.66e+06. What is the difference between the Aid flow from UN agencies (US$) in Mexico in 2005 and the Aid flow from UN agencies (US$) in Rwanda in 2012?
Your answer should be very brief. -1.02e+07. What is the difference between the Aid flow from UN agencies (US$) of Lower middle income in 2009 and the Aid flow from UN agencies (US$) of Small states in 2010?
Provide a succinct answer. 3.85e+07. What is the difference between the Aid flow from UN agencies (US$) in Lower middle income in 2009 and the Aid flow from UN agencies (US$) in Mexico in 2010?
Your response must be concise. 4.22e+07. What is the difference between the Aid flow from UN agencies (US$) in Lower middle income in 2009 and the Aid flow from UN agencies (US$) in Rwanda in 2010?
Keep it short and to the point. 4.11e+07. What is the difference between the Aid flow from UN agencies (US$) in Small states in 2009 and the Aid flow from UN agencies (US$) in Mexico in 2010?
Give a very brief answer. 5.55e+06. What is the difference between the Aid flow from UN agencies (US$) in Small states in 2009 and the Aid flow from UN agencies (US$) in Rwanda in 2010?
Provide a succinct answer. 4.44e+06. What is the difference between the Aid flow from UN agencies (US$) in Mexico in 2009 and the Aid flow from UN agencies (US$) in Rwanda in 2010?
Your answer should be compact. -5.70e+05. What is the difference between the Aid flow from UN agencies (US$) of Lower middle income in 2009 and the Aid flow from UN agencies (US$) of Small states in 2012?
Ensure brevity in your answer.  3.77e+07. What is the difference between the Aid flow from UN agencies (US$) of Lower middle income in 2009 and the Aid flow from UN agencies (US$) of Mexico in 2012?
Make the answer very short. 4.12e+07. What is the difference between the Aid flow from UN agencies (US$) in Lower middle income in 2009 and the Aid flow from UN agencies (US$) in Rwanda in 2012?
Offer a terse response. 3.13e+07. What is the difference between the Aid flow from UN agencies (US$) of Small states in 2009 and the Aid flow from UN agencies (US$) of Mexico in 2012?
Your answer should be very brief. 4.54e+06. What is the difference between the Aid flow from UN agencies (US$) in Small states in 2009 and the Aid flow from UN agencies (US$) in Rwanda in 2012?
Provide a short and direct response. -5.30e+06. What is the difference between the Aid flow from UN agencies (US$) of Mexico in 2009 and the Aid flow from UN agencies (US$) of Rwanda in 2012?
Provide a succinct answer. -1.03e+07. What is the difference between the Aid flow from UN agencies (US$) in Lower middle income in 2010 and the Aid flow from UN agencies (US$) in Small states in 2012?
Your answer should be compact. 7.31e+07. What is the difference between the Aid flow from UN agencies (US$) of Lower middle income in 2010 and the Aid flow from UN agencies (US$) of Mexico in 2012?
Offer a very short reply. 7.66e+07. What is the difference between the Aid flow from UN agencies (US$) in Lower middle income in 2010 and the Aid flow from UN agencies (US$) in Rwanda in 2012?
Provide a short and direct response. 6.68e+07. What is the difference between the Aid flow from UN agencies (US$) in Small states in 2010 and the Aid flow from UN agencies (US$) in Mexico in 2012?
Provide a succinct answer. 2.64e+06. What is the difference between the Aid flow from UN agencies (US$) of Small states in 2010 and the Aid flow from UN agencies (US$) of Rwanda in 2012?
Ensure brevity in your answer.  -7.20e+06. What is the difference between the Aid flow from UN agencies (US$) of Mexico in 2010 and the Aid flow from UN agencies (US$) of Rwanda in 2012?
Your answer should be very brief. -1.08e+07. What is the average Aid flow from UN agencies (US$) of Lower middle income per year?
Make the answer very short. 7.88e+07. What is the average Aid flow from UN agencies (US$) of Small states per year?
Offer a terse response. 9.78e+06. What is the average Aid flow from UN agencies (US$) in Mexico per year?
Your answer should be compact. 1.58e+06. What is the average Aid flow from UN agencies (US$) in Rwanda per year?
Offer a terse response. 4.98e+06. In the year 2001, what is the difference between the Aid flow from UN agencies (US$) in Lower middle income and Aid flow from UN agencies (US$) in Small states?
Your answer should be very brief. 7.98e+07. In the year 2001, what is the difference between the Aid flow from UN agencies (US$) of Lower middle income and Aid flow from UN agencies (US$) of Mexico?
Provide a short and direct response. 9.34e+07. In the year 2001, what is the difference between the Aid flow from UN agencies (US$) in Lower middle income and Aid flow from UN agencies (US$) in Rwanda?
Your response must be concise. 9.02e+07. In the year 2001, what is the difference between the Aid flow from UN agencies (US$) of Small states and Aid flow from UN agencies (US$) of Mexico?
Keep it short and to the point. 1.36e+07. In the year 2001, what is the difference between the Aid flow from UN agencies (US$) of Small states and Aid flow from UN agencies (US$) of Rwanda?
Provide a succinct answer. 1.04e+07. In the year 2001, what is the difference between the Aid flow from UN agencies (US$) in Mexico and Aid flow from UN agencies (US$) in Rwanda?
Your answer should be very brief. -3.25e+06. In the year 2002, what is the difference between the Aid flow from UN agencies (US$) in Lower middle income and Aid flow from UN agencies (US$) in Small states?
Ensure brevity in your answer.  9.46e+07. In the year 2002, what is the difference between the Aid flow from UN agencies (US$) of Lower middle income and Aid flow from UN agencies (US$) of Mexico?
Keep it short and to the point. 1.08e+08. In the year 2002, what is the difference between the Aid flow from UN agencies (US$) of Lower middle income and Aid flow from UN agencies (US$) of Rwanda?
Provide a short and direct response. 1.03e+08. In the year 2002, what is the difference between the Aid flow from UN agencies (US$) of Small states and Aid flow from UN agencies (US$) of Mexico?
Make the answer very short. 1.36e+07. In the year 2002, what is the difference between the Aid flow from UN agencies (US$) in Small states and Aid flow from UN agencies (US$) in Rwanda?
Your answer should be compact. 8.47e+06. In the year 2002, what is the difference between the Aid flow from UN agencies (US$) of Mexico and Aid flow from UN agencies (US$) of Rwanda?
Provide a short and direct response. -5.15e+06. In the year 2003, what is the difference between the Aid flow from UN agencies (US$) in Lower middle income and Aid flow from UN agencies (US$) in Small states?
Give a very brief answer. 8.46e+07. In the year 2003, what is the difference between the Aid flow from UN agencies (US$) of Lower middle income and Aid flow from UN agencies (US$) of Mexico?
Your answer should be compact. 9.64e+07. In the year 2003, what is the difference between the Aid flow from UN agencies (US$) of Lower middle income and Aid flow from UN agencies (US$) of Rwanda?
Offer a very short reply. 9.24e+07. In the year 2003, what is the difference between the Aid flow from UN agencies (US$) of Small states and Aid flow from UN agencies (US$) of Mexico?
Offer a terse response. 1.17e+07. In the year 2003, what is the difference between the Aid flow from UN agencies (US$) in Small states and Aid flow from UN agencies (US$) in Rwanda?
Offer a very short reply. 7.81e+06. In the year 2003, what is the difference between the Aid flow from UN agencies (US$) in Mexico and Aid flow from UN agencies (US$) in Rwanda?
Provide a short and direct response. -3.92e+06. In the year 2004, what is the difference between the Aid flow from UN agencies (US$) of Lower middle income and Aid flow from UN agencies (US$) of Small states?
Offer a terse response. 7.80e+07. In the year 2004, what is the difference between the Aid flow from UN agencies (US$) of Lower middle income and Aid flow from UN agencies (US$) of Mexico?
Your answer should be very brief. 8.99e+07. In the year 2004, what is the difference between the Aid flow from UN agencies (US$) in Lower middle income and Aid flow from UN agencies (US$) in Rwanda?
Make the answer very short. 8.70e+07. In the year 2004, what is the difference between the Aid flow from UN agencies (US$) in Small states and Aid flow from UN agencies (US$) in Mexico?
Ensure brevity in your answer.  1.19e+07. In the year 2004, what is the difference between the Aid flow from UN agencies (US$) of Small states and Aid flow from UN agencies (US$) of Rwanda?
Your answer should be compact. 8.94e+06. In the year 2004, what is the difference between the Aid flow from UN agencies (US$) of Mexico and Aid flow from UN agencies (US$) of Rwanda?
Keep it short and to the point. -2.94e+06. In the year 2005, what is the difference between the Aid flow from UN agencies (US$) of Lower middle income and Aid flow from UN agencies (US$) of Small states?
Ensure brevity in your answer.  2.65e+07. In the year 2005, what is the difference between the Aid flow from UN agencies (US$) in Lower middle income and Aid flow from UN agencies (US$) in Mexico?
Keep it short and to the point. 2.90e+07. In the year 2005, what is the difference between the Aid flow from UN agencies (US$) of Lower middle income and Aid flow from UN agencies (US$) of Rwanda?
Offer a very short reply. 2.93e+07. In the year 2005, what is the difference between the Aid flow from UN agencies (US$) in Small states and Aid flow from UN agencies (US$) in Mexico?
Your answer should be compact. 2.51e+06. In the year 2005, what is the difference between the Aid flow from UN agencies (US$) in Small states and Aid flow from UN agencies (US$) in Rwanda?
Offer a terse response. 2.76e+06. In the year 2005, what is the difference between the Aid flow from UN agencies (US$) of Mexico and Aid flow from UN agencies (US$) of Rwanda?
Your answer should be compact. 2.50e+05. In the year 2009, what is the difference between the Aid flow from UN agencies (US$) in Lower middle income and Aid flow from UN agencies (US$) in Small states?
Provide a succinct answer. 3.66e+07. In the year 2009, what is the difference between the Aid flow from UN agencies (US$) in Lower middle income and Aid flow from UN agencies (US$) in Mexico?
Ensure brevity in your answer.  4.16e+07. In the year 2009, what is the difference between the Aid flow from UN agencies (US$) of Lower middle income and Aid flow from UN agencies (US$) of Rwanda?
Offer a very short reply. 4.04e+07. In the year 2009, what is the difference between the Aid flow from UN agencies (US$) in Small states and Aid flow from UN agencies (US$) in Mexico?
Provide a short and direct response. 5.01e+06. In the year 2009, what is the difference between the Aid flow from UN agencies (US$) of Small states and Aid flow from UN agencies (US$) of Rwanda?
Keep it short and to the point. 3.78e+06. In the year 2009, what is the difference between the Aid flow from UN agencies (US$) in Mexico and Aid flow from UN agencies (US$) in Rwanda?
Make the answer very short. -1.23e+06. In the year 2010, what is the difference between the Aid flow from UN agencies (US$) of Lower middle income and Aid flow from UN agencies (US$) of Small states?
Offer a terse response. 7.40e+07. In the year 2010, what is the difference between the Aid flow from UN agencies (US$) of Lower middle income and Aid flow from UN agencies (US$) of Mexico?
Offer a very short reply. 7.76e+07. In the year 2010, what is the difference between the Aid flow from UN agencies (US$) of Lower middle income and Aid flow from UN agencies (US$) of Rwanda?
Make the answer very short. 7.65e+07. In the year 2010, what is the difference between the Aid flow from UN agencies (US$) of Small states and Aid flow from UN agencies (US$) of Mexico?
Offer a very short reply. 3.65e+06. In the year 2010, what is the difference between the Aid flow from UN agencies (US$) of Small states and Aid flow from UN agencies (US$) of Rwanda?
Provide a succinct answer. 2.54e+06. In the year 2010, what is the difference between the Aid flow from UN agencies (US$) in Mexico and Aid flow from UN agencies (US$) in Rwanda?
Provide a succinct answer. -1.11e+06. In the year 2012, what is the difference between the Aid flow from UN agencies (US$) of Lower middle income and Aid flow from UN agencies (US$) of Small states?
Keep it short and to the point. 7.80e+07. In the year 2012, what is the difference between the Aid flow from UN agencies (US$) of Lower middle income and Aid flow from UN agencies (US$) of Mexico?
Make the answer very short. 8.16e+07. In the year 2012, what is the difference between the Aid flow from UN agencies (US$) of Lower middle income and Aid flow from UN agencies (US$) of Rwanda?
Provide a short and direct response. 7.17e+07. In the year 2012, what is the difference between the Aid flow from UN agencies (US$) of Small states and Aid flow from UN agencies (US$) of Mexico?
Your answer should be very brief. 3.51e+06. In the year 2012, what is the difference between the Aid flow from UN agencies (US$) in Small states and Aid flow from UN agencies (US$) in Rwanda?
Provide a succinct answer. -6.33e+06. In the year 2012, what is the difference between the Aid flow from UN agencies (US$) in Mexico and Aid flow from UN agencies (US$) in Rwanda?
Make the answer very short. -9.84e+06. What is the ratio of the Aid flow from UN agencies (US$) in Lower middle income in 2001 to that in 2002?
Your answer should be compact. 0.89. What is the ratio of the Aid flow from UN agencies (US$) in Small states in 2001 to that in 2002?
Keep it short and to the point. 1.16. What is the ratio of the Aid flow from UN agencies (US$) of Mexico in 2001 to that in 2002?
Your response must be concise. 2.39. What is the ratio of the Aid flow from UN agencies (US$) of Rwanda in 2001 to that in 2002?
Give a very brief answer. 1.08. What is the ratio of the Aid flow from UN agencies (US$) of Lower middle income in 2001 to that in 2003?
Offer a terse response. 1. What is the ratio of the Aid flow from UN agencies (US$) of Small states in 2001 to that in 2003?
Offer a very short reply. 1.35. What is the ratio of the Aid flow from UN agencies (US$) of Mexico in 2001 to that in 2003?
Provide a succinct answer. 2.82. What is the ratio of the Aid flow from UN agencies (US$) of Rwanda in 2001 to that in 2003?
Provide a succinct answer. 1.38. What is the ratio of the Aid flow from UN agencies (US$) in Lower middle income in 2001 to that in 2004?
Provide a short and direct response. 1.07. What is the ratio of the Aid flow from UN agencies (US$) in Small states in 2001 to that in 2004?
Provide a short and direct response. 1.33. What is the ratio of the Aid flow from UN agencies (US$) of Mexico in 2001 to that in 2004?
Keep it short and to the point. 2.82. What is the ratio of the Aid flow from UN agencies (US$) of Rwanda in 2001 to that in 2004?
Keep it short and to the point. 1.68. What is the ratio of the Aid flow from UN agencies (US$) in Lower middle income in 2001 to that in 2005?
Offer a terse response. 3.24. What is the ratio of the Aid flow from UN agencies (US$) in Small states in 2001 to that in 2005?
Provide a succinct answer. 4.97. What is the ratio of the Aid flow from UN agencies (US$) of Mexico in 2001 to that in 2005?
Your answer should be compact. 3.91. What is the ratio of the Aid flow from UN agencies (US$) of Rwanda in 2001 to that in 2005?
Ensure brevity in your answer.  9.06. What is the ratio of the Aid flow from UN agencies (US$) in Lower middle income in 2001 to that in 2009?
Make the answer very short. 2.29. What is the ratio of the Aid flow from UN agencies (US$) in Small states in 2001 to that in 2009?
Your response must be concise. 3. What is the ratio of the Aid flow from UN agencies (US$) in Mexico in 2001 to that in 2009?
Keep it short and to the point. 4.49. What is the ratio of the Aid flow from UN agencies (US$) of Rwanda in 2001 to that in 2009?
Make the answer very short. 3.44. What is the ratio of the Aid flow from UN agencies (US$) in Lower middle income in 2001 to that in 2010?
Your answer should be compact. 1.25. What is the ratio of the Aid flow from UN agencies (US$) of Small states in 2001 to that in 2010?
Your answer should be compact. 4.41. What is the ratio of the Aid flow from UN agencies (US$) in Mexico in 2001 to that in 2010?
Give a very brief answer. 10.72. What is the ratio of the Aid flow from UN agencies (US$) of Rwanda in 2001 to that in 2010?
Provide a succinct answer. 4.95. What is the ratio of the Aid flow from UN agencies (US$) in Lower middle income in 2001 to that in 2012?
Keep it short and to the point. 1.18. What is the ratio of the Aid flow from UN agencies (US$) of Small states in 2001 to that in 2012?
Your answer should be compact. 3.63. What is the ratio of the Aid flow from UN agencies (US$) in Mexico in 2001 to that in 2012?
Provide a short and direct response. 2.99. What is the ratio of the Aid flow from UN agencies (US$) in Rwanda in 2001 to that in 2012?
Your response must be concise. 0.66. What is the ratio of the Aid flow from UN agencies (US$) in Lower middle income in 2002 to that in 2003?
Provide a succinct answer. 1.12. What is the ratio of the Aid flow from UN agencies (US$) of Small states in 2002 to that in 2003?
Keep it short and to the point. 1.16. What is the ratio of the Aid flow from UN agencies (US$) of Mexico in 2002 to that in 2003?
Provide a succinct answer. 1.18. What is the ratio of the Aid flow from UN agencies (US$) in Rwanda in 2002 to that in 2003?
Offer a terse response. 1.28. What is the ratio of the Aid flow from UN agencies (US$) of Lower middle income in 2002 to that in 2004?
Ensure brevity in your answer.  1.2. What is the ratio of the Aid flow from UN agencies (US$) of Small states in 2002 to that in 2004?
Provide a succinct answer. 1.15. What is the ratio of the Aid flow from UN agencies (US$) in Mexico in 2002 to that in 2004?
Offer a very short reply. 1.18. What is the ratio of the Aid flow from UN agencies (US$) of Rwanda in 2002 to that in 2004?
Make the answer very short. 1.56. What is the ratio of the Aid flow from UN agencies (US$) of Lower middle income in 2002 to that in 2005?
Your answer should be very brief. 3.65. What is the ratio of the Aid flow from UN agencies (US$) in Small states in 2002 to that in 2005?
Ensure brevity in your answer.  4.29. What is the ratio of the Aid flow from UN agencies (US$) in Mexico in 2002 to that in 2005?
Your answer should be compact. 1.64. What is the ratio of the Aid flow from UN agencies (US$) in Rwanda in 2002 to that in 2005?
Offer a terse response. 8.41. What is the ratio of the Aid flow from UN agencies (US$) of Lower middle income in 2002 to that in 2009?
Offer a terse response. 2.58. What is the ratio of the Aid flow from UN agencies (US$) of Small states in 2002 to that in 2009?
Offer a terse response. 2.59. What is the ratio of the Aid flow from UN agencies (US$) in Mexico in 2002 to that in 2009?
Provide a short and direct response. 1.88. What is the ratio of the Aid flow from UN agencies (US$) in Rwanda in 2002 to that in 2009?
Offer a terse response. 3.19. What is the ratio of the Aid flow from UN agencies (US$) of Lower middle income in 2002 to that in 2010?
Offer a terse response. 1.41. What is the ratio of the Aid flow from UN agencies (US$) of Small states in 2002 to that in 2010?
Keep it short and to the point. 3.8. What is the ratio of the Aid flow from UN agencies (US$) in Mexico in 2002 to that in 2010?
Your answer should be compact. 4.49. What is the ratio of the Aid flow from UN agencies (US$) of Rwanda in 2002 to that in 2010?
Keep it short and to the point. 4.6. What is the ratio of the Aid flow from UN agencies (US$) of Lower middle income in 2002 to that in 2012?
Your answer should be very brief. 1.33. What is the ratio of the Aid flow from UN agencies (US$) of Small states in 2002 to that in 2012?
Your answer should be very brief. 3.13. What is the ratio of the Aid flow from UN agencies (US$) in Mexico in 2002 to that in 2012?
Provide a short and direct response. 1.25. What is the ratio of the Aid flow from UN agencies (US$) of Rwanda in 2002 to that in 2012?
Keep it short and to the point. 0.61. What is the ratio of the Aid flow from UN agencies (US$) in Lower middle income in 2003 to that in 2004?
Offer a terse response. 1.07. What is the ratio of the Aid flow from UN agencies (US$) in Rwanda in 2003 to that in 2004?
Your response must be concise. 1.22. What is the ratio of the Aid flow from UN agencies (US$) in Lower middle income in 2003 to that in 2005?
Offer a terse response. 3.25. What is the ratio of the Aid flow from UN agencies (US$) in Small states in 2003 to that in 2005?
Offer a terse response. 3.69. What is the ratio of the Aid flow from UN agencies (US$) of Mexico in 2003 to that in 2005?
Ensure brevity in your answer.  1.38. What is the ratio of the Aid flow from UN agencies (US$) of Rwanda in 2003 to that in 2005?
Your answer should be compact. 6.59. What is the ratio of the Aid flow from UN agencies (US$) in Lower middle income in 2003 to that in 2009?
Make the answer very short. 2.3. What is the ratio of the Aid flow from UN agencies (US$) of Small states in 2003 to that in 2009?
Make the answer very short. 2.22. What is the ratio of the Aid flow from UN agencies (US$) of Mexico in 2003 to that in 2009?
Keep it short and to the point. 1.59. What is the ratio of the Aid flow from UN agencies (US$) of Rwanda in 2003 to that in 2009?
Offer a terse response. 2.5. What is the ratio of the Aid flow from UN agencies (US$) of Lower middle income in 2003 to that in 2010?
Give a very brief answer. 1.25. What is the ratio of the Aid flow from UN agencies (US$) in Small states in 2003 to that in 2010?
Give a very brief answer. 3.27. What is the ratio of the Aid flow from UN agencies (US$) in Mexico in 2003 to that in 2010?
Offer a very short reply. 3.79. What is the ratio of the Aid flow from UN agencies (US$) in Lower middle income in 2003 to that in 2012?
Make the answer very short. 1.18. What is the ratio of the Aid flow from UN agencies (US$) in Small states in 2003 to that in 2012?
Your answer should be compact. 2.69. What is the ratio of the Aid flow from UN agencies (US$) in Mexico in 2003 to that in 2012?
Provide a short and direct response. 1.06. What is the ratio of the Aid flow from UN agencies (US$) of Rwanda in 2003 to that in 2012?
Keep it short and to the point. 0.48. What is the ratio of the Aid flow from UN agencies (US$) of Lower middle income in 2004 to that in 2005?
Your answer should be compact. 3.04. What is the ratio of the Aid flow from UN agencies (US$) of Small states in 2004 to that in 2005?
Your answer should be very brief. 3.73. What is the ratio of the Aid flow from UN agencies (US$) in Mexico in 2004 to that in 2005?
Offer a terse response. 1.38. What is the ratio of the Aid flow from UN agencies (US$) in Rwanda in 2004 to that in 2005?
Your response must be concise. 5.39. What is the ratio of the Aid flow from UN agencies (US$) of Lower middle income in 2004 to that in 2009?
Offer a very short reply. 2.15. What is the ratio of the Aid flow from UN agencies (US$) in Small states in 2004 to that in 2009?
Ensure brevity in your answer.  2.25. What is the ratio of the Aid flow from UN agencies (US$) in Mexico in 2004 to that in 2009?
Give a very brief answer. 1.59. What is the ratio of the Aid flow from UN agencies (US$) in Rwanda in 2004 to that in 2009?
Offer a terse response. 2.05. What is the ratio of the Aid flow from UN agencies (US$) in Lower middle income in 2004 to that in 2010?
Keep it short and to the point. 1.17. What is the ratio of the Aid flow from UN agencies (US$) in Small states in 2004 to that in 2010?
Make the answer very short. 3.31. What is the ratio of the Aid flow from UN agencies (US$) in Mexico in 2004 to that in 2010?
Give a very brief answer. 3.79. What is the ratio of the Aid flow from UN agencies (US$) in Rwanda in 2004 to that in 2010?
Make the answer very short. 2.95. What is the ratio of the Aid flow from UN agencies (US$) of Lower middle income in 2004 to that in 2012?
Offer a terse response. 1.1. What is the ratio of the Aid flow from UN agencies (US$) of Small states in 2004 to that in 2012?
Your answer should be compact. 2.72. What is the ratio of the Aid flow from UN agencies (US$) in Mexico in 2004 to that in 2012?
Your answer should be very brief. 1.06. What is the ratio of the Aid flow from UN agencies (US$) of Rwanda in 2004 to that in 2012?
Offer a very short reply. 0.39. What is the ratio of the Aid flow from UN agencies (US$) in Lower middle income in 2005 to that in 2009?
Your response must be concise. 0.71. What is the ratio of the Aid flow from UN agencies (US$) of Small states in 2005 to that in 2009?
Offer a terse response. 0.6. What is the ratio of the Aid flow from UN agencies (US$) of Mexico in 2005 to that in 2009?
Give a very brief answer. 1.15. What is the ratio of the Aid flow from UN agencies (US$) in Rwanda in 2005 to that in 2009?
Keep it short and to the point. 0.38. What is the ratio of the Aid flow from UN agencies (US$) of Lower middle income in 2005 to that in 2010?
Your answer should be very brief. 0.39. What is the ratio of the Aid flow from UN agencies (US$) in Small states in 2005 to that in 2010?
Offer a very short reply. 0.89. What is the ratio of the Aid flow from UN agencies (US$) of Mexico in 2005 to that in 2010?
Give a very brief answer. 2.74. What is the ratio of the Aid flow from UN agencies (US$) of Rwanda in 2005 to that in 2010?
Your answer should be compact. 0.55. What is the ratio of the Aid flow from UN agencies (US$) of Lower middle income in 2005 to that in 2012?
Ensure brevity in your answer.  0.36. What is the ratio of the Aid flow from UN agencies (US$) of Small states in 2005 to that in 2012?
Give a very brief answer. 0.73. What is the ratio of the Aid flow from UN agencies (US$) in Mexico in 2005 to that in 2012?
Give a very brief answer. 0.76. What is the ratio of the Aid flow from UN agencies (US$) in Rwanda in 2005 to that in 2012?
Your answer should be compact. 0.07. What is the ratio of the Aid flow from UN agencies (US$) of Lower middle income in 2009 to that in 2010?
Your response must be concise. 0.55. What is the ratio of the Aid flow from UN agencies (US$) in Small states in 2009 to that in 2010?
Provide a succinct answer. 1.47. What is the ratio of the Aid flow from UN agencies (US$) in Mexico in 2009 to that in 2010?
Ensure brevity in your answer.  2.38. What is the ratio of the Aid flow from UN agencies (US$) in Rwanda in 2009 to that in 2010?
Give a very brief answer. 1.44. What is the ratio of the Aid flow from UN agencies (US$) in Lower middle income in 2009 to that in 2012?
Keep it short and to the point. 0.51. What is the ratio of the Aid flow from UN agencies (US$) of Small states in 2009 to that in 2012?
Keep it short and to the point. 1.21. What is the ratio of the Aid flow from UN agencies (US$) of Mexico in 2009 to that in 2012?
Ensure brevity in your answer.  0.66. What is the ratio of the Aid flow from UN agencies (US$) of Rwanda in 2009 to that in 2012?
Your answer should be very brief. 0.19. What is the ratio of the Aid flow from UN agencies (US$) of Lower middle income in 2010 to that in 2012?
Keep it short and to the point. 0.94. What is the ratio of the Aid flow from UN agencies (US$) in Small states in 2010 to that in 2012?
Keep it short and to the point. 0.82. What is the ratio of the Aid flow from UN agencies (US$) of Mexico in 2010 to that in 2012?
Your answer should be compact. 0.28. What is the ratio of the Aid flow from UN agencies (US$) in Rwanda in 2010 to that in 2012?
Keep it short and to the point. 0.13. What is the difference between the highest and the second highest Aid flow from UN agencies (US$) of Lower middle income?
Make the answer very short. 1.21e+07. What is the difference between the highest and the second highest Aid flow from UN agencies (US$) of Small states?
Your answer should be very brief. 2.44e+06. What is the difference between the highest and the second highest Aid flow from UN agencies (US$) of Mexico?
Your response must be concise. 2.43e+06. What is the difference between the highest and the second highest Aid flow from UN agencies (US$) of Rwanda?
Offer a terse response. 3.81e+06. What is the difference between the highest and the lowest Aid flow from UN agencies (US$) of Lower middle income?
Your response must be concise. 7.98e+07. What is the difference between the highest and the lowest Aid flow from UN agencies (US$) of Small states?
Your answer should be compact. 1.42e+07. What is the difference between the highest and the lowest Aid flow from UN agencies (US$) in Mexico?
Your answer should be compact. 3.79e+06. What is the difference between the highest and the lowest Aid flow from UN agencies (US$) of Rwanda?
Offer a very short reply. 1.04e+07. 